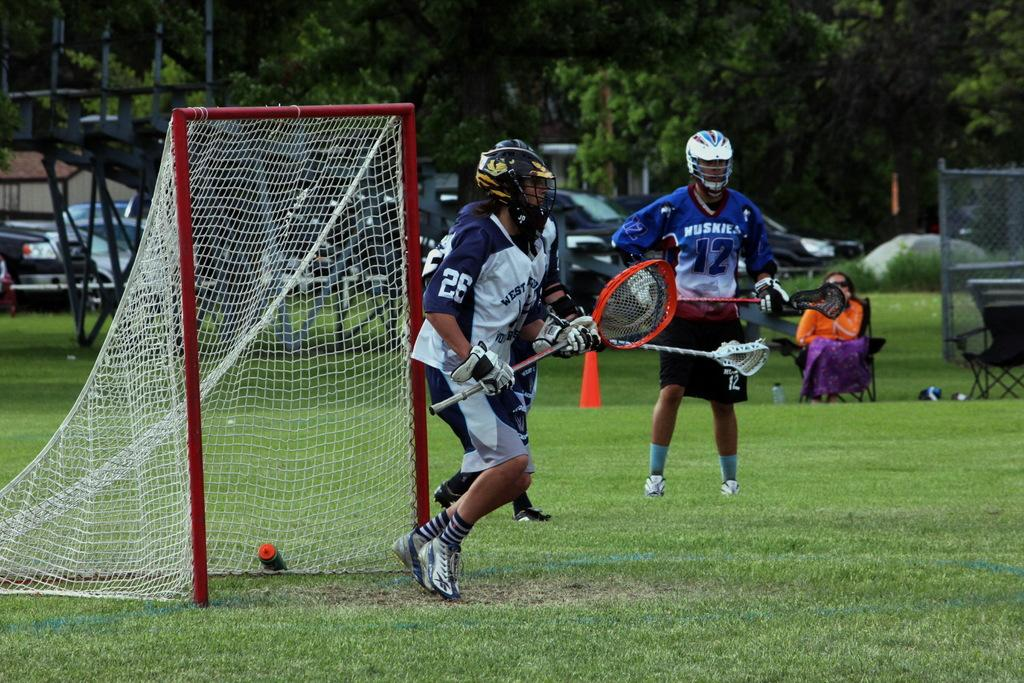<image>
Write a terse but informative summary of the picture. Player number 26 is in the goal while player number 12 stands nearby. 